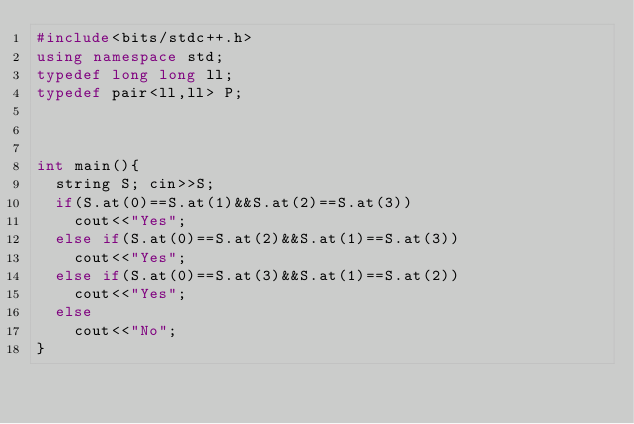Convert code to text. <code><loc_0><loc_0><loc_500><loc_500><_C++_>#include<bits/stdc++.h>
using namespace std;
typedef long long ll;
typedef pair<ll,ll> P;



int main(){
  string S; cin>>S;
  if(S.at(0)==S.at(1)&&S.at(2)==S.at(3))
    cout<<"Yes";
  else if(S.at(0)==S.at(2)&&S.at(1)==S.at(3))
    cout<<"Yes";
  else if(S.at(0)==S.at(3)&&S.at(1)==S.at(2))
    cout<<"Yes";
  else
    cout<<"No";
}</code> 